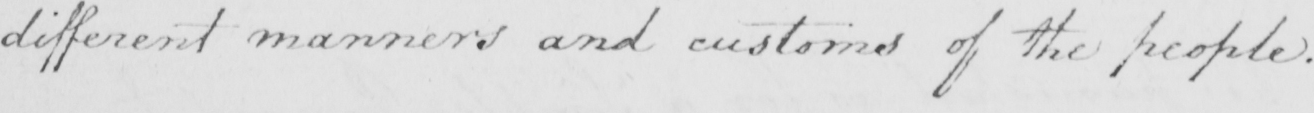What text is written in this handwritten line? different manners and customs of the people . 